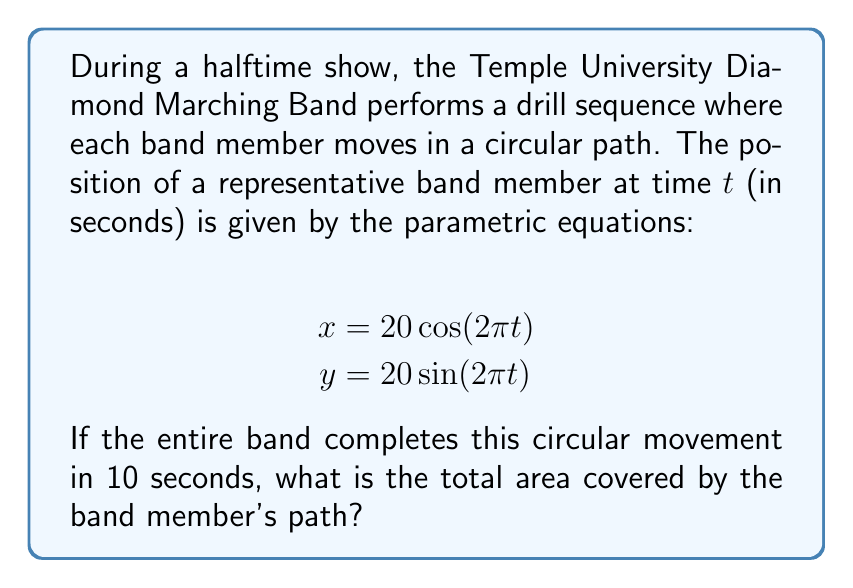Could you help me with this problem? To find the area covered by the band member's path, we need to calculate the area of the circle described by the parametric equations. Let's approach this step-by-step:

1) First, we recognize that these parametric equations describe a circle. We can see this because:
   $$x^2 + y^2 = (20\cos(2\pi t))^2 + (20\sin(2\pi t))^2 = 400(\cos^2(2\pi t) + \sin^2(2\pi t)) = 400$$

2) This is the equation of a circle with radius 20 units, centered at the origin (0,0).

3) The area of a circle is given by the formula $A = \pi r^2$, where $r$ is the radius.

4) In this case, $r = 20$, so:
   $$A = \pi (20)^2 = 400\pi$$

5) However, we need to be careful about the units. The question doesn't specify any units for the parametric equations, so we'll assume they're in yards (a common unit for marching band field measurements).

6) Therefore, the area is $400\pi$ square yards.

Note: The fact that the movement takes 10 seconds doesn't affect the area calculation. It would only be relevant if we were calculating the band member's speed or the distance traveled.
Answer: The total area covered by the band member's path is $400\pi$ square yards, or approximately 1256.64 square yards. 